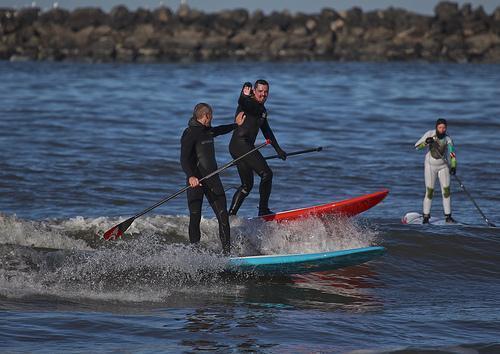How many people are riding surfboards?
Give a very brief answer. 3. 